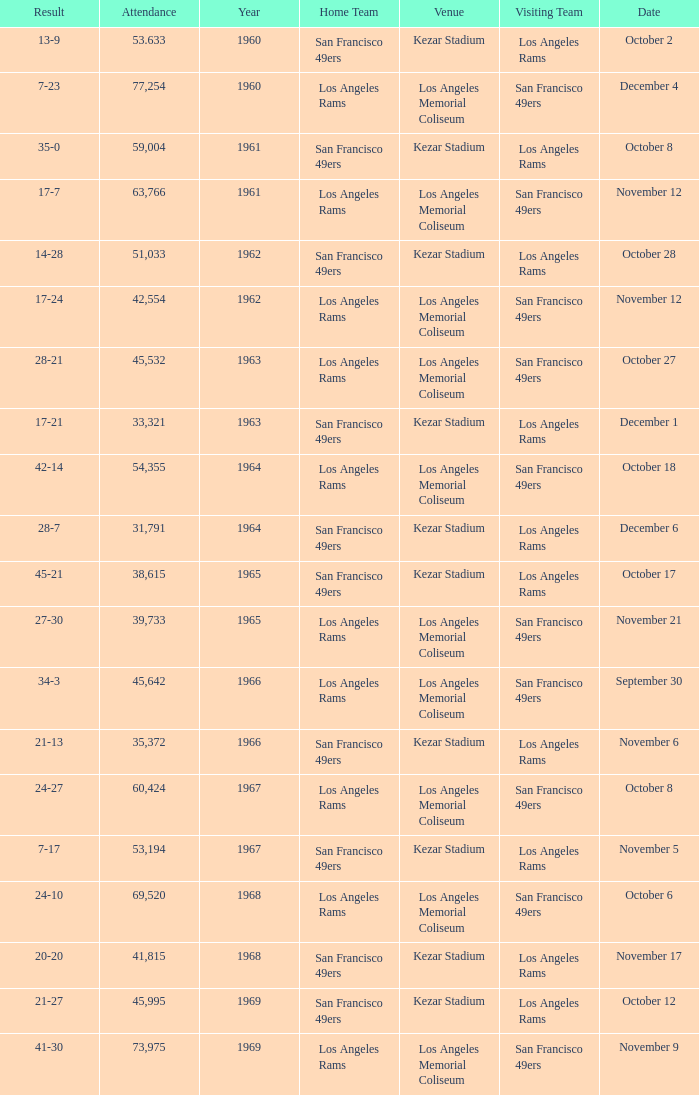Who is the home team when the san francisco 49ers are visiting with a result of 42-14? Los Angeles Rams. 